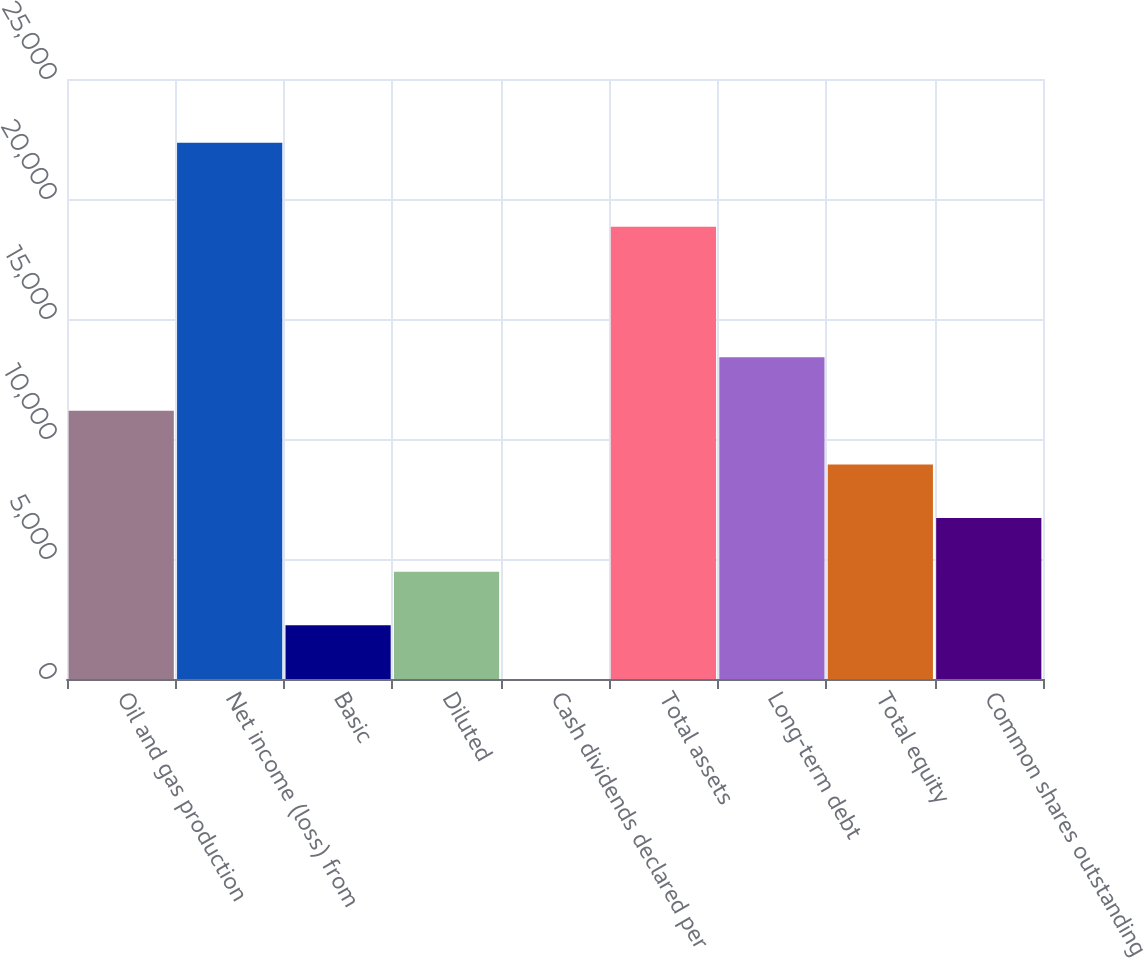Convert chart to OTSL. <chart><loc_0><loc_0><loc_500><loc_500><bar_chart><fcel>Oil and gas production<fcel>Net income (loss) from<fcel>Basic<fcel>Diluted<fcel>Cash dividends declared per<fcel>Total assets<fcel>Long-term debt<fcel>Total equity<fcel>Common shares outstanding<nl><fcel>11174.5<fcel>22348<fcel>2235.7<fcel>4470.4<fcel>1<fcel>18842<fcel>13409.2<fcel>8939.8<fcel>6705.1<nl></chart> 